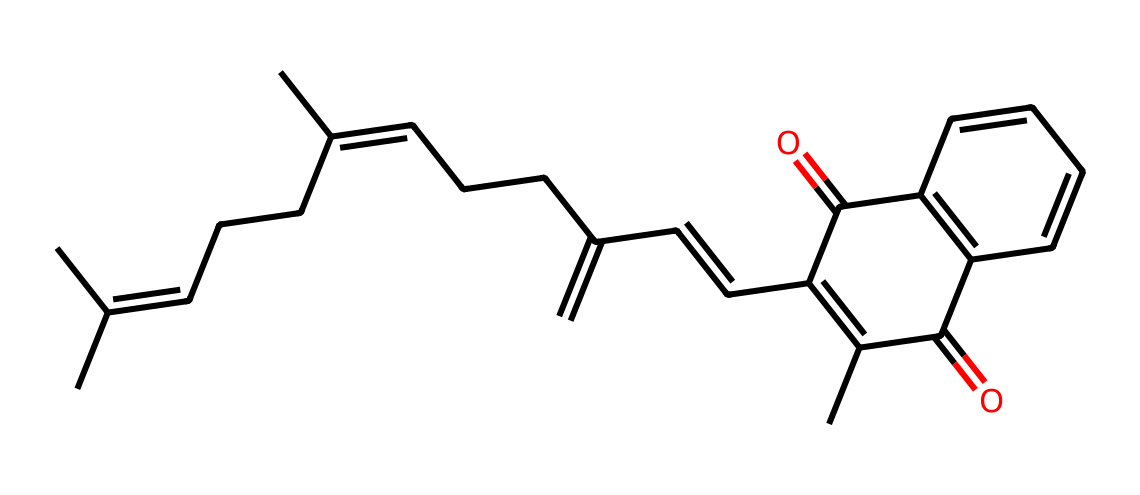What is the molecular formula of this vitamin? To determine the molecular formula, we need to identify the number of carbon (C), hydrogen (H), and oxygen (O) atoms present in the structure. By analyzing the provided SMILES, we observe there are 30 carbons, 46 hydrogens, and 2 oxygens. Therefore, the molecular formula is C30H46O2.
Answer: C30H46O2 How many rings are present in the structure? By analyzing the structure in the SMILES notation, we can see that there are two distinct rings present (indicated by the repeated numbers that denote where the ring closes). Hence, the total count of rings in this vitamin's structure is 2.
Answer: 2 Is this vitamin hydrophobic or hydrophilic? Given the predominantly hydrocarbon nature and the presence of a limited number of polar groups (only two hydroxyls), this compound is mainly hydrophobic. Thus, it is more soluble in oils than in water.
Answer: hydrophobic What type of vitamin is represented by this structure? This structure corresponds to vitamin K, which is crucial for blood coagulation. As it is recognized for facilitating the synthesis of proteins, the classification can be derived based on its known functions and structure.
Answer: vitamin K What potential advanced material could be developed using this vitamin? Considering the structural stability and potential lightweight nature associated with the compounds, advanced composite materials such as bio-based polymers or nanocomposites could be proposed for UAV applications.
Answer: bio-based polymers In this vitamin, how many double bonds are there? By carefully examining the structure, we can identify that the presence of double bonds is indicated by the unsaturated carbon atoms. The analysis shows there are a total of 6 double bonds in the entire structure.
Answer: 6 